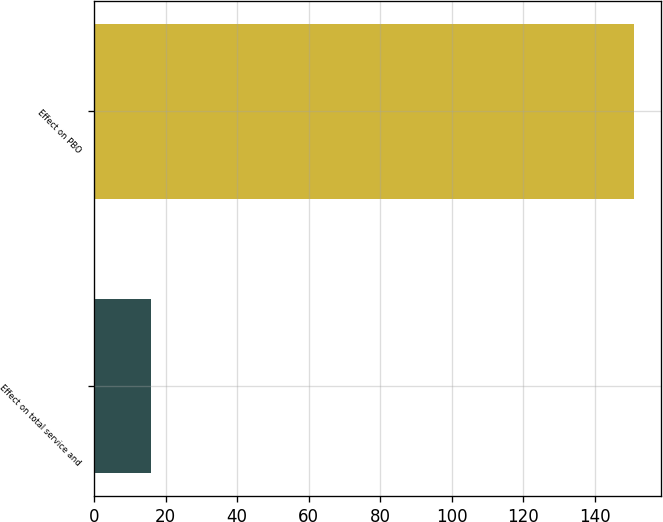<chart> <loc_0><loc_0><loc_500><loc_500><bar_chart><fcel>Effect on total service and<fcel>Effect on PBO<nl><fcel>16<fcel>151<nl></chart> 